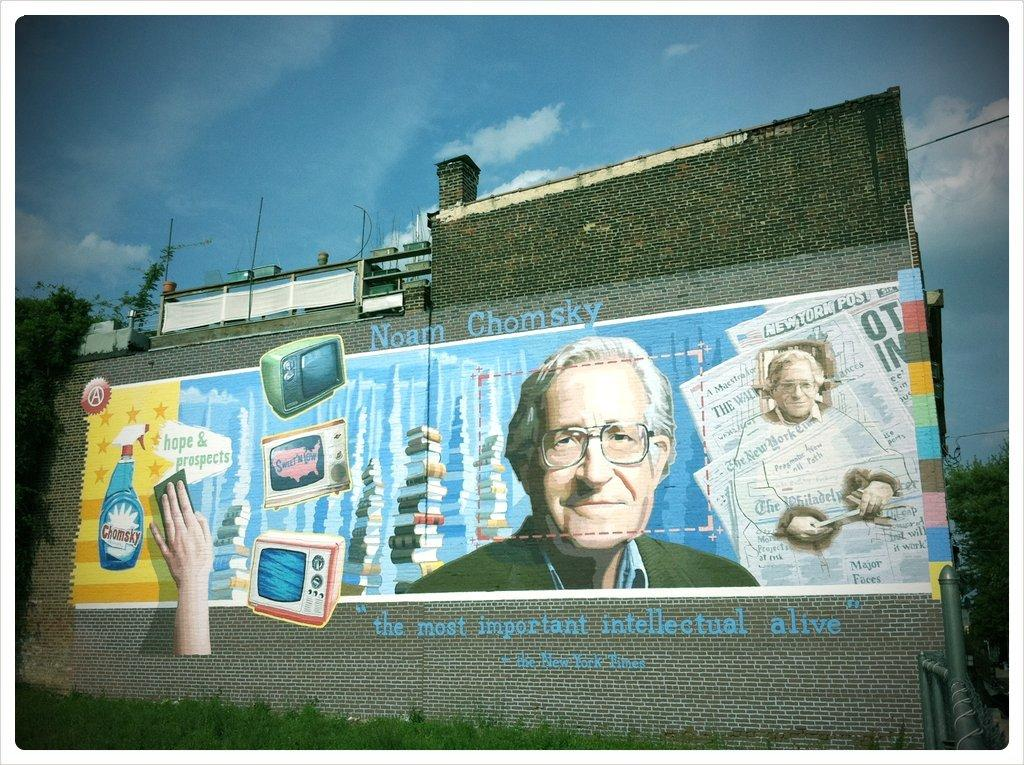<image>
Share a concise interpretation of the image provided. a mural on a building that says 'noam chomsky' above it 